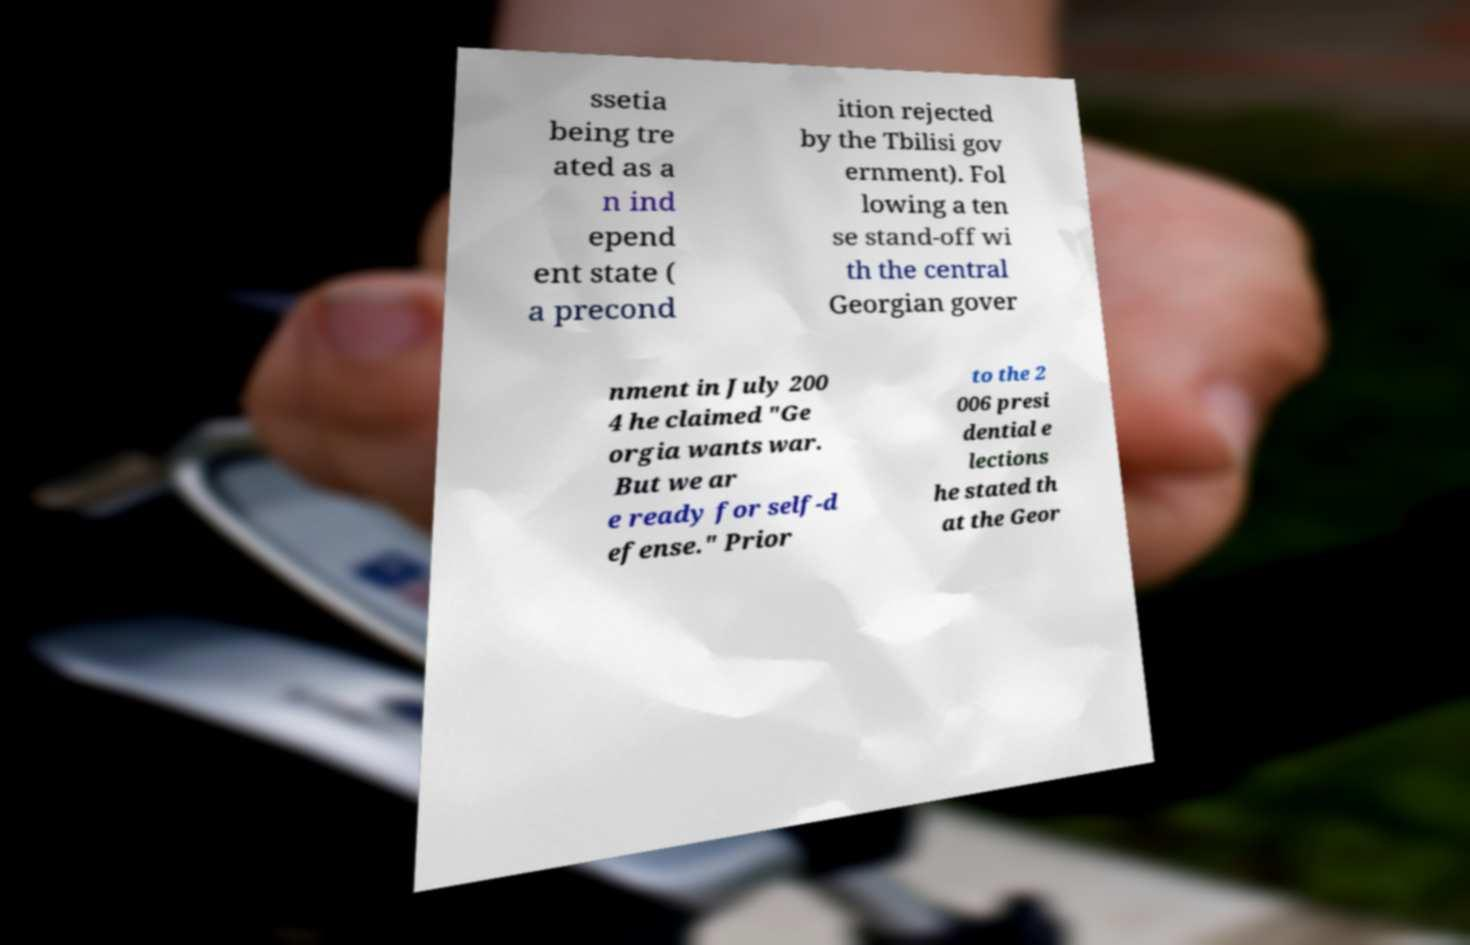I need the written content from this picture converted into text. Can you do that? ssetia being tre ated as a n ind epend ent state ( a precond ition rejected by the Tbilisi gov ernment). Fol lowing a ten se stand-off wi th the central Georgian gover nment in July 200 4 he claimed "Ge orgia wants war. But we ar e ready for self-d efense." Prior to the 2 006 presi dential e lections he stated th at the Geor 